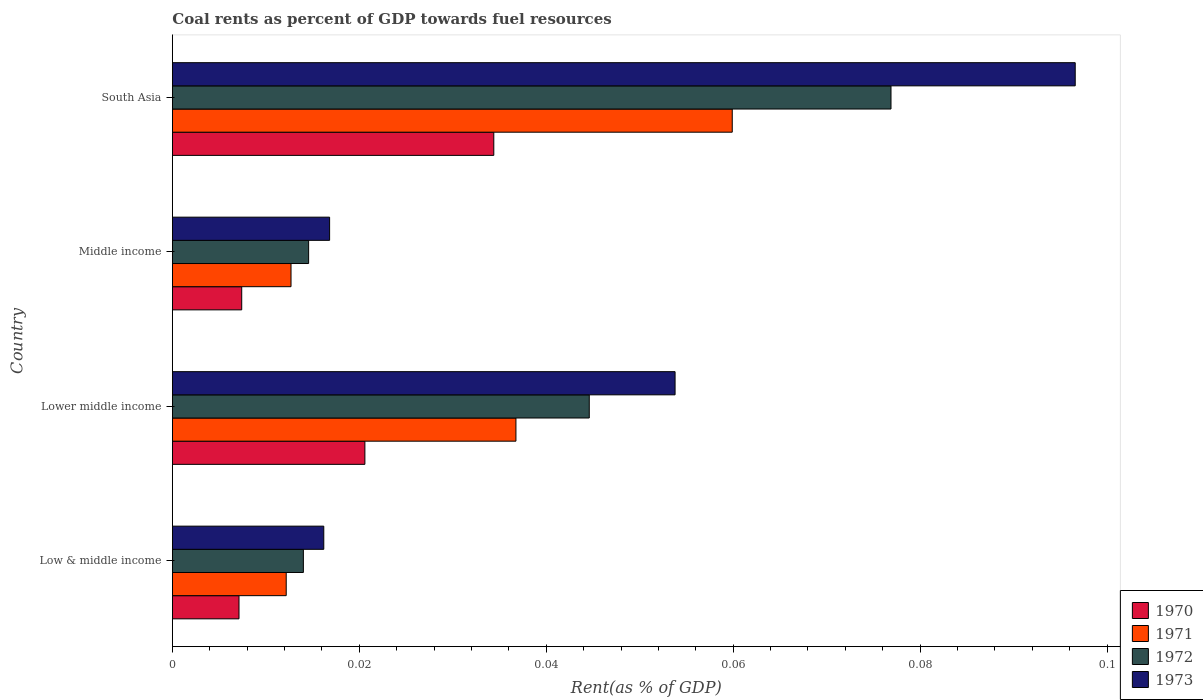How many bars are there on the 4th tick from the top?
Your answer should be compact. 4. How many bars are there on the 4th tick from the bottom?
Provide a short and direct response. 4. What is the label of the 1st group of bars from the top?
Your response must be concise. South Asia. What is the coal rent in 1972 in South Asia?
Your answer should be very brief. 0.08. Across all countries, what is the maximum coal rent in 1972?
Offer a terse response. 0.08. Across all countries, what is the minimum coal rent in 1973?
Your answer should be compact. 0.02. In which country was the coal rent in 1973 maximum?
Make the answer very short. South Asia. In which country was the coal rent in 1973 minimum?
Provide a short and direct response. Low & middle income. What is the total coal rent in 1973 in the graph?
Offer a very short reply. 0.18. What is the difference between the coal rent in 1970 in Low & middle income and that in Lower middle income?
Your response must be concise. -0.01. What is the difference between the coal rent in 1971 in Lower middle income and the coal rent in 1973 in Low & middle income?
Ensure brevity in your answer.  0.02. What is the average coal rent in 1970 per country?
Make the answer very short. 0.02. What is the difference between the coal rent in 1972 and coal rent in 1971 in Lower middle income?
Keep it short and to the point. 0.01. What is the ratio of the coal rent in 1971 in Low & middle income to that in Lower middle income?
Your answer should be very brief. 0.33. Is the coal rent in 1970 in Lower middle income less than that in South Asia?
Your response must be concise. Yes. Is the difference between the coal rent in 1972 in Lower middle income and Middle income greater than the difference between the coal rent in 1971 in Lower middle income and Middle income?
Ensure brevity in your answer.  Yes. What is the difference between the highest and the second highest coal rent in 1972?
Make the answer very short. 0.03. What is the difference between the highest and the lowest coal rent in 1971?
Keep it short and to the point. 0.05. Is the sum of the coal rent in 1971 in Lower middle income and Middle income greater than the maximum coal rent in 1973 across all countries?
Your answer should be compact. No. What does the 1st bar from the bottom in Lower middle income represents?
Provide a succinct answer. 1970. Is it the case that in every country, the sum of the coal rent in 1970 and coal rent in 1973 is greater than the coal rent in 1971?
Make the answer very short. Yes. How many bars are there?
Keep it short and to the point. 16. Are all the bars in the graph horizontal?
Offer a terse response. Yes. What is the difference between two consecutive major ticks on the X-axis?
Your answer should be compact. 0.02. Does the graph contain any zero values?
Provide a succinct answer. No. Does the graph contain grids?
Give a very brief answer. No. Where does the legend appear in the graph?
Provide a succinct answer. Bottom right. How many legend labels are there?
Give a very brief answer. 4. What is the title of the graph?
Give a very brief answer. Coal rents as percent of GDP towards fuel resources. What is the label or title of the X-axis?
Offer a very short reply. Rent(as % of GDP). What is the Rent(as % of GDP) of 1970 in Low & middle income?
Ensure brevity in your answer.  0.01. What is the Rent(as % of GDP) in 1971 in Low & middle income?
Provide a succinct answer. 0.01. What is the Rent(as % of GDP) of 1972 in Low & middle income?
Make the answer very short. 0.01. What is the Rent(as % of GDP) of 1973 in Low & middle income?
Provide a succinct answer. 0.02. What is the Rent(as % of GDP) in 1970 in Lower middle income?
Offer a very short reply. 0.02. What is the Rent(as % of GDP) of 1971 in Lower middle income?
Offer a very short reply. 0.04. What is the Rent(as % of GDP) of 1972 in Lower middle income?
Keep it short and to the point. 0.04. What is the Rent(as % of GDP) in 1973 in Lower middle income?
Offer a very short reply. 0.05. What is the Rent(as % of GDP) of 1970 in Middle income?
Offer a very short reply. 0.01. What is the Rent(as % of GDP) of 1971 in Middle income?
Make the answer very short. 0.01. What is the Rent(as % of GDP) in 1972 in Middle income?
Provide a succinct answer. 0.01. What is the Rent(as % of GDP) of 1973 in Middle income?
Ensure brevity in your answer.  0.02. What is the Rent(as % of GDP) in 1970 in South Asia?
Offer a terse response. 0.03. What is the Rent(as % of GDP) of 1971 in South Asia?
Your answer should be very brief. 0.06. What is the Rent(as % of GDP) of 1972 in South Asia?
Your response must be concise. 0.08. What is the Rent(as % of GDP) in 1973 in South Asia?
Keep it short and to the point. 0.1. Across all countries, what is the maximum Rent(as % of GDP) in 1970?
Offer a terse response. 0.03. Across all countries, what is the maximum Rent(as % of GDP) of 1971?
Offer a terse response. 0.06. Across all countries, what is the maximum Rent(as % of GDP) in 1972?
Provide a succinct answer. 0.08. Across all countries, what is the maximum Rent(as % of GDP) in 1973?
Your answer should be compact. 0.1. Across all countries, what is the minimum Rent(as % of GDP) in 1970?
Provide a short and direct response. 0.01. Across all countries, what is the minimum Rent(as % of GDP) in 1971?
Your response must be concise. 0.01. Across all countries, what is the minimum Rent(as % of GDP) of 1972?
Your answer should be compact. 0.01. Across all countries, what is the minimum Rent(as % of GDP) in 1973?
Give a very brief answer. 0.02. What is the total Rent(as % of GDP) in 1970 in the graph?
Your response must be concise. 0.07. What is the total Rent(as % of GDP) in 1971 in the graph?
Your answer should be compact. 0.12. What is the total Rent(as % of GDP) in 1972 in the graph?
Provide a short and direct response. 0.15. What is the total Rent(as % of GDP) in 1973 in the graph?
Ensure brevity in your answer.  0.18. What is the difference between the Rent(as % of GDP) of 1970 in Low & middle income and that in Lower middle income?
Provide a short and direct response. -0.01. What is the difference between the Rent(as % of GDP) of 1971 in Low & middle income and that in Lower middle income?
Your answer should be compact. -0.02. What is the difference between the Rent(as % of GDP) in 1972 in Low & middle income and that in Lower middle income?
Offer a terse response. -0.03. What is the difference between the Rent(as % of GDP) of 1973 in Low & middle income and that in Lower middle income?
Provide a succinct answer. -0.04. What is the difference between the Rent(as % of GDP) of 1970 in Low & middle income and that in Middle income?
Your answer should be very brief. -0. What is the difference between the Rent(as % of GDP) of 1971 in Low & middle income and that in Middle income?
Provide a succinct answer. -0. What is the difference between the Rent(as % of GDP) in 1972 in Low & middle income and that in Middle income?
Make the answer very short. -0. What is the difference between the Rent(as % of GDP) in 1973 in Low & middle income and that in Middle income?
Make the answer very short. -0. What is the difference between the Rent(as % of GDP) of 1970 in Low & middle income and that in South Asia?
Your response must be concise. -0.03. What is the difference between the Rent(as % of GDP) of 1971 in Low & middle income and that in South Asia?
Offer a terse response. -0.05. What is the difference between the Rent(as % of GDP) in 1972 in Low & middle income and that in South Asia?
Your response must be concise. -0.06. What is the difference between the Rent(as % of GDP) of 1973 in Low & middle income and that in South Asia?
Ensure brevity in your answer.  -0.08. What is the difference between the Rent(as % of GDP) of 1970 in Lower middle income and that in Middle income?
Ensure brevity in your answer.  0.01. What is the difference between the Rent(as % of GDP) in 1971 in Lower middle income and that in Middle income?
Provide a succinct answer. 0.02. What is the difference between the Rent(as % of GDP) in 1972 in Lower middle income and that in Middle income?
Keep it short and to the point. 0.03. What is the difference between the Rent(as % of GDP) of 1973 in Lower middle income and that in Middle income?
Provide a short and direct response. 0.04. What is the difference between the Rent(as % of GDP) in 1970 in Lower middle income and that in South Asia?
Your answer should be very brief. -0.01. What is the difference between the Rent(as % of GDP) of 1971 in Lower middle income and that in South Asia?
Your answer should be compact. -0.02. What is the difference between the Rent(as % of GDP) of 1972 in Lower middle income and that in South Asia?
Provide a short and direct response. -0.03. What is the difference between the Rent(as % of GDP) in 1973 in Lower middle income and that in South Asia?
Give a very brief answer. -0.04. What is the difference between the Rent(as % of GDP) of 1970 in Middle income and that in South Asia?
Give a very brief answer. -0.03. What is the difference between the Rent(as % of GDP) of 1971 in Middle income and that in South Asia?
Make the answer very short. -0.05. What is the difference between the Rent(as % of GDP) in 1972 in Middle income and that in South Asia?
Provide a short and direct response. -0.06. What is the difference between the Rent(as % of GDP) in 1973 in Middle income and that in South Asia?
Your answer should be very brief. -0.08. What is the difference between the Rent(as % of GDP) in 1970 in Low & middle income and the Rent(as % of GDP) in 1971 in Lower middle income?
Provide a succinct answer. -0.03. What is the difference between the Rent(as % of GDP) in 1970 in Low & middle income and the Rent(as % of GDP) in 1972 in Lower middle income?
Offer a very short reply. -0.04. What is the difference between the Rent(as % of GDP) of 1970 in Low & middle income and the Rent(as % of GDP) of 1973 in Lower middle income?
Your answer should be very brief. -0.05. What is the difference between the Rent(as % of GDP) of 1971 in Low & middle income and the Rent(as % of GDP) of 1972 in Lower middle income?
Give a very brief answer. -0.03. What is the difference between the Rent(as % of GDP) in 1971 in Low & middle income and the Rent(as % of GDP) in 1973 in Lower middle income?
Keep it short and to the point. -0.04. What is the difference between the Rent(as % of GDP) of 1972 in Low & middle income and the Rent(as % of GDP) of 1973 in Lower middle income?
Your response must be concise. -0.04. What is the difference between the Rent(as % of GDP) of 1970 in Low & middle income and the Rent(as % of GDP) of 1971 in Middle income?
Offer a terse response. -0.01. What is the difference between the Rent(as % of GDP) in 1970 in Low & middle income and the Rent(as % of GDP) in 1972 in Middle income?
Your answer should be compact. -0.01. What is the difference between the Rent(as % of GDP) of 1970 in Low & middle income and the Rent(as % of GDP) of 1973 in Middle income?
Offer a terse response. -0.01. What is the difference between the Rent(as % of GDP) in 1971 in Low & middle income and the Rent(as % of GDP) in 1972 in Middle income?
Keep it short and to the point. -0. What is the difference between the Rent(as % of GDP) of 1971 in Low & middle income and the Rent(as % of GDP) of 1973 in Middle income?
Give a very brief answer. -0. What is the difference between the Rent(as % of GDP) in 1972 in Low & middle income and the Rent(as % of GDP) in 1973 in Middle income?
Make the answer very short. -0. What is the difference between the Rent(as % of GDP) in 1970 in Low & middle income and the Rent(as % of GDP) in 1971 in South Asia?
Keep it short and to the point. -0.05. What is the difference between the Rent(as % of GDP) of 1970 in Low & middle income and the Rent(as % of GDP) of 1972 in South Asia?
Offer a terse response. -0.07. What is the difference between the Rent(as % of GDP) of 1970 in Low & middle income and the Rent(as % of GDP) of 1973 in South Asia?
Provide a succinct answer. -0.09. What is the difference between the Rent(as % of GDP) of 1971 in Low & middle income and the Rent(as % of GDP) of 1972 in South Asia?
Offer a terse response. -0.06. What is the difference between the Rent(as % of GDP) in 1971 in Low & middle income and the Rent(as % of GDP) in 1973 in South Asia?
Your response must be concise. -0.08. What is the difference between the Rent(as % of GDP) of 1972 in Low & middle income and the Rent(as % of GDP) of 1973 in South Asia?
Your answer should be compact. -0.08. What is the difference between the Rent(as % of GDP) in 1970 in Lower middle income and the Rent(as % of GDP) in 1971 in Middle income?
Offer a very short reply. 0.01. What is the difference between the Rent(as % of GDP) in 1970 in Lower middle income and the Rent(as % of GDP) in 1972 in Middle income?
Offer a terse response. 0.01. What is the difference between the Rent(as % of GDP) in 1970 in Lower middle income and the Rent(as % of GDP) in 1973 in Middle income?
Your answer should be compact. 0. What is the difference between the Rent(as % of GDP) of 1971 in Lower middle income and the Rent(as % of GDP) of 1972 in Middle income?
Provide a short and direct response. 0.02. What is the difference between the Rent(as % of GDP) in 1971 in Lower middle income and the Rent(as % of GDP) in 1973 in Middle income?
Your response must be concise. 0.02. What is the difference between the Rent(as % of GDP) of 1972 in Lower middle income and the Rent(as % of GDP) of 1973 in Middle income?
Make the answer very short. 0.03. What is the difference between the Rent(as % of GDP) in 1970 in Lower middle income and the Rent(as % of GDP) in 1971 in South Asia?
Your response must be concise. -0.04. What is the difference between the Rent(as % of GDP) in 1970 in Lower middle income and the Rent(as % of GDP) in 1972 in South Asia?
Your response must be concise. -0.06. What is the difference between the Rent(as % of GDP) of 1970 in Lower middle income and the Rent(as % of GDP) of 1973 in South Asia?
Provide a short and direct response. -0.08. What is the difference between the Rent(as % of GDP) in 1971 in Lower middle income and the Rent(as % of GDP) in 1972 in South Asia?
Provide a succinct answer. -0.04. What is the difference between the Rent(as % of GDP) of 1971 in Lower middle income and the Rent(as % of GDP) of 1973 in South Asia?
Your answer should be compact. -0.06. What is the difference between the Rent(as % of GDP) in 1972 in Lower middle income and the Rent(as % of GDP) in 1973 in South Asia?
Ensure brevity in your answer.  -0.05. What is the difference between the Rent(as % of GDP) of 1970 in Middle income and the Rent(as % of GDP) of 1971 in South Asia?
Your answer should be compact. -0.05. What is the difference between the Rent(as % of GDP) in 1970 in Middle income and the Rent(as % of GDP) in 1972 in South Asia?
Your response must be concise. -0.07. What is the difference between the Rent(as % of GDP) in 1970 in Middle income and the Rent(as % of GDP) in 1973 in South Asia?
Keep it short and to the point. -0.09. What is the difference between the Rent(as % of GDP) of 1971 in Middle income and the Rent(as % of GDP) of 1972 in South Asia?
Your response must be concise. -0.06. What is the difference between the Rent(as % of GDP) in 1971 in Middle income and the Rent(as % of GDP) in 1973 in South Asia?
Your answer should be compact. -0.08. What is the difference between the Rent(as % of GDP) in 1972 in Middle income and the Rent(as % of GDP) in 1973 in South Asia?
Keep it short and to the point. -0.08. What is the average Rent(as % of GDP) of 1970 per country?
Ensure brevity in your answer.  0.02. What is the average Rent(as % of GDP) of 1971 per country?
Ensure brevity in your answer.  0.03. What is the average Rent(as % of GDP) of 1972 per country?
Offer a terse response. 0.04. What is the average Rent(as % of GDP) of 1973 per country?
Provide a short and direct response. 0.05. What is the difference between the Rent(as % of GDP) in 1970 and Rent(as % of GDP) in 1971 in Low & middle income?
Your response must be concise. -0.01. What is the difference between the Rent(as % of GDP) of 1970 and Rent(as % of GDP) of 1972 in Low & middle income?
Provide a succinct answer. -0.01. What is the difference between the Rent(as % of GDP) in 1970 and Rent(as % of GDP) in 1973 in Low & middle income?
Provide a succinct answer. -0.01. What is the difference between the Rent(as % of GDP) in 1971 and Rent(as % of GDP) in 1972 in Low & middle income?
Your response must be concise. -0. What is the difference between the Rent(as % of GDP) in 1971 and Rent(as % of GDP) in 1973 in Low & middle income?
Your answer should be very brief. -0. What is the difference between the Rent(as % of GDP) in 1972 and Rent(as % of GDP) in 1973 in Low & middle income?
Give a very brief answer. -0. What is the difference between the Rent(as % of GDP) of 1970 and Rent(as % of GDP) of 1971 in Lower middle income?
Keep it short and to the point. -0.02. What is the difference between the Rent(as % of GDP) in 1970 and Rent(as % of GDP) in 1972 in Lower middle income?
Offer a very short reply. -0.02. What is the difference between the Rent(as % of GDP) in 1970 and Rent(as % of GDP) in 1973 in Lower middle income?
Ensure brevity in your answer.  -0.03. What is the difference between the Rent(as % of GDP) of 1971 and Rent(as % of GDP) of 1972 in Lower middle income?
Provide a succinct answer. -0.01. What is the difference between the Rent(as % of GDP) in 1971 and Rent(as % of GDP) in 1973 in Lower middle income?
Keep it short and to the point. -0.02. What is the difference between the Rent(as % of GDP) in 1972 and Rent(as % of GDP) in 1973 in Lower middle income?
Your response must be concise. -0.01. What is the difference between the Rent(as % of GDP) in 1970 and Rent(as % of GDP) in 1971 in Middle income?
Offer a very short reply. -0.01. What is the difference between the Rent(as % of GDP) of 1970 and Rent(as % of GDP) of 1972 in Middle income?
Offer a terse response. -0.01. What is the difference between the Rent(as % of GDP) in 1970 and Rent(as % of GDP) in 1973 in Middle income?
Provide a short and direct response. -0.01. What is the difference between the Rent(as % of GDP) of 1971 and Rent(as % of GDP) of 1972 in Middle income?
Give a very brief answer. -0. What is the difference between the Rent(as % of GDP) of 1971 and Rent(as % of GDP) of 1973 in Middle income?
Your response must be concise. -0. What is the difference between the Rent(as % of GDP) in 1972 and Rent(as % of GDP) in 1973 in Middle income?
Your answer should be compact. -0. What is the difference between the Rent(as % of GDP) in 1970 and Rent(as % of GDP) in 1971 in South Asia?
Provide a short and direct response. -0.03. What is the difference between the Rent(as % of GDP) of 1970 and Rent(as % of GDP) of 1972 in South Asia?
Give a very brief answer. -0.04. What is the difference between the Rent(as % of GDP) of 1970 and Rent(as % of GDP) of 1973 in South Asia?
Provide a short and direct response. -0.06. What is the difference between the Rent(as % of GDP) in 1971 and Rent(as % of GDP) in 1972 in South Asia?
Ensure brevity in your answer.  -0.02. What is the difference between the Rent(as % of GDP) of 1971 and Rent(as % of GDP) of 1973 in South Asia?
Your answer should be very brief. -0.04. What is the difference between the Rent(as % of GDP) in 1972 and Rent(as % of GDP) in 1973 in South Asia?
Your response must be concise. -0.02. What is the ratio of the Rent(as % of GDP) of 1970 in Low & middle income to that in Lower middle income?
Offer a very short reply. 0.35. What is the ratio of the Rent(as % of GDP) of 1971 in Low & middle income to that in Lower middle income?
Offer a terse response. 0.33. What is the ratio of the Rent(as % of GDP) in 1972 in Low & middle income to that in Lower middle income?
Ensure brevity in your answer.  0.31. What is the ratio of the Rent(as % of GDP) in 1973 in Low & middle income to that in Lower middle income?
Offer a very short reply. 0.3. What is the ratio of the Rent(as % of GDP) of 1970 in Low & middle income to that in Middle income?
Provide a short and direct response. 0.96. What is the ratio of the Rent(as % of GDP) in 1971 in Low & middle income to that in Middle income?
Your answer should be very brief. 0.96. What is the ratio of the Rent(as % of GDP) of 1972 in Low & middle income to that in Middle income?
Offer a terse response. 0.96. What is the ratio of the Rent(as % of GDP) of 1973 in Low & middle income to that in Middle income?
Provide a short and direct response. 0.96. What is the ratio of the Rent(as % of GDP) of 1970 in Low & middle income to that in South Asia?
Give a very brief answer. 0.21. What is the ratio of the Rent(as % of GDP) in 1971 in Low & middle income to that in South Asia?
Provide a succinct answer. 0.2. What is the ratio of the Rent(as % of GDP) of 1972 in Low & middle income to that in South Asia?
Your answer should be compact. 0.18. What is the ratio of the Rent(as % of GDP) in 1973 in Low & middle income to that in South Asia?
Your answer should be very brief. 0.17. What is the ratio of the Rent(as % of GDP) of 1970 in Lower middle income to that in Middle income?
Your answer should be compact. 2.78. What is the ratio of the Rent(as % of GDP) in 1971 in Lower middle income to that in Middle income?
Make the answer very short. 2.9. What is the ratio of the Rent(as % of GDP) of 1972 in Lower middle income to that in Middle income?
Give a very brief answer. 3.06. What is the ratio of the Rent(as % of GDP) of 1973 in Lower middle income to that in Middle income?
Provide a succinct answer. 3.2. What is the ratio of the Rent(as % of GDP) in 1970 in Lower middle income to that in South Asia?
Provide a succinct answer. 0.6. What is the ratio of the Rent(as % of GDP) of 1971 in Lower middle income to that in South Asia?
Keep it short and to the point. 0.61. What is the ratio of the Rent(as % of GDP) in 1972 in Lower middle income to that in South Asia?
Offer a very short reply. 0.58. What is the ratio of the Rent(as % of GDP) in 1973 in Lower middle income to that in South Asia?
Provide a short and direct response. 0.56. What is the ratio of the Rent(as % of GDP) of 1970 in Middle income to that in South Asia?
Provide a succinct answer. 0.22. What is the ratio of the Rent(as % of GDP) in 1971 in Middle income to that in South Asia?
Your answer should be compact. 0.21. What is the ratio of the Rent(as % of GDP) of 1972 in Middle income to that in South Asia?
Your answer should be compact. 0.19. What is the ratio of the Rent(as % of GDP) in 1973 in Middle income to that in South Asia?
Provide a short and direct response. 0.17. What is the difference between the highest and the second highest Rent(as % of GDP) in 1970?
Offer a very short reply. 0.01. What is the difference between the highest and the second highest Rent(as % of GDP) of 1971?
Give a very brief answer. 0.02. What is the difference between the highest and the second highest Rent(as % of GDP) in 1972?
Your answer should be compact. 0.03. What is the difference between the highest and the second highest Rent(as % of GDP) of 1973?
Offer a very short reply. 0.04. What is the difference between the highest and the lowest Rent(as % of GDP) of 1970?
Give a very brief answer. 0.03. What is the difference between the highest and the lowest Rent(as % of GDP) in 1971?
Your answer should be compact. 0.05. What is the difference between the highest and the lowest Rent(as % of GDP) of 1972?
Offer a terse response. 0.06. What is the difference between the highest and the lowest Rent(as % of GDP) of 1973?
Give a very brief answer. 0.08. 